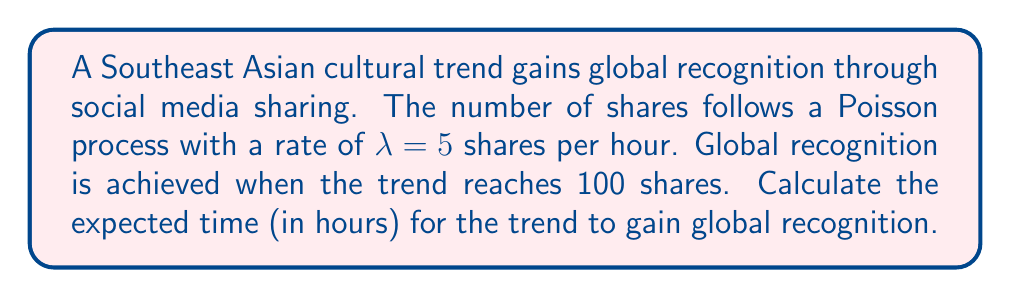Solve this math problem. Let's approach this step-by-step using the properties of Poisson processes:

1) In a Poisson process, the time until a specific number of events occur follows an Erlang distribution.

2) The Erlang distribution is a special case of the Gamma distribution where the shape parameter is an integer.

3) For our case:
   - The rate parameter is $\lambda = 5$ shares/hour
   - We need to wait for 100 shares (events)

4) The expected value of an Erlang distribution is given by:

   $$E[T] = \frac{k}{\lambda}$$

   Where:
   $k$ is the number of events we're waiting for
   $\lambda$ is the rate parameter of the Poisson process

5) Substituting our values:

   $$E[T] = \frac{100}{5} = 20$$

6) Therefore, the expected time for the trend to gain global recognition is 20 hours.
Answer: 20 hours 